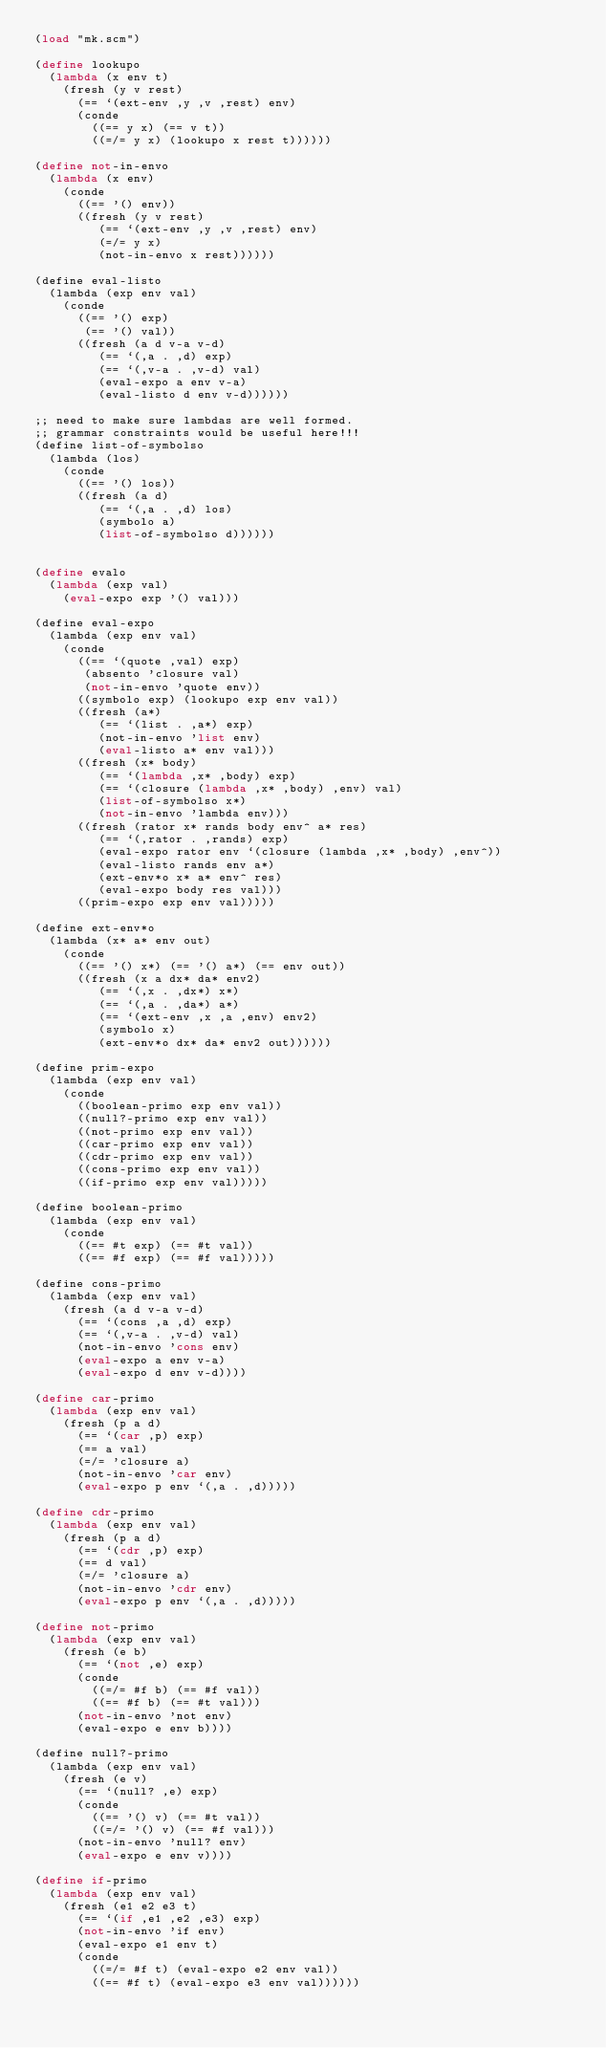<code> <loc_0><loc_0><loc_500><loc_500><_Scheme_>(load "mk.scm")

(define lookupo
  (lambda (x env t)
    (fresh (y v rest)
      (== `(ext-env ,y ,v ,rest) env)
      (conde
        ((== y x) (== v t))
        ((=/= y x) (lookupo x rest t))))))

(define not-in-envo
  (lambda (x env)
    (conde
      ((== '() env))
      ((fresh (y v rest)
         (== `(ext-env ,y ,v ,rest) env)
         (=/= y x)
         (not-in-envo x rest))))))

(define eval-listo
  (lambda (exp env val)
    (conde
      ((== '() exp)
       (== '() val))
      ((fresh (a d v-a v-d)
         (== `(,a . ,d) exp)
         (== `(,v-a . ,v-d) val)
         (eval-expo a env v-a)
         (eval-listo d env v-d))))))

;; need to make sure lambdas are well formed.
;; grammar constraints would be useful here!!!
(define list-of-symbolso
  (lambda (los)
    (conde
      ((== '() los))
      ((fresh (a d)
         (== `(,a . ,d) los)
         (symbolo a)
         (list-of-symbolso d))))))


(define evalo
  (lambda (exp val)
    (eval-expo exp '() val)))

(define eval-expo
  (lambda (exp env val)
    (conde
      ((== `(quote ,val) exp)
       (absento 'closure val)
       (not-in-envo 'quote env))
      ((symbolo exp) (lookupo exp env val))
      ((fresh (a*)
         (== `(list . ,a*) exp)
         (not-in-envo 'list env)
         (eval-listo a* env val)))
      ((fresh (x* body)
         (== `(lambda ,x* ,body) exp)
         (== `(closure (lambda ,x* ,body) ,env) val)
         (list-of-symbolso x*)
         (not-in-envo 'lambda env)))
      ((fresh (rator x* rands body env^ a* res)
         (== `(,rator . ,rands) exp)
         (eval-expo rator env `(closure (lambda ,x* ,body) ,env^))
         (eval-listo rands env a*)
         (ext-env*o x* a* env^ res)
         (eval-expo body res val)))
      ((prim-expo exp env val)))))

(define ext-env*o
  (lambda (x* a* env out)
    (conde
      ((== '() x*) (== '() a*) (== env out))
      ((fresh (x a dx* da* env2)
         (== `(,x . ,dx*) x*)
         (== `(,a . ,da*) a*)
         (== `(ext-env ,x ,a ,env) env2)
         (symbolo x)
         (ext-env*o dx* da* env2 out))))))

(define prim-expo
  (lambda (exp env val)
    (conde
      ((boolean-primo exp env val))
      ((null?-primo exp env val))
      ((not-primo exp env val))
      ((car-primo exp env val))
      ((cdr-primo exp env val))
      ((cons-primo exp env val))
      ((if-primo exp env val)))))

(define boolean-primo
  (lambda (exp env val)
    (conde
      ((== #t exp) (== #t val))
      ((== #f exp) (== #f val)))))

(define cons-primo
  (lambda (exp env val)
    (fresh (a d v-a v-d)
      (== `(cons ,a ,d) exp)
      (== `(,v-a . ,v-d) val)
      (not-in-envo 'cons env)
      (eval-expo a env v-a)
      (eval-expo d env v-d))))

(define car-primo
  (lambda (exp env val)
    (fresh (p a d)
      (== `(car ,p) exp)
      (== a val)
      (=/= 'closure a)
      (not-in-envo 'car env)
      (eval-expo p env `(,a . ,d)))))

(define cdr-primo
  (lambda (exp env val)
    (fresh (p a d)
      (== `(cdr ,p) exp)
      (== d val)
      (=/= 'closure a)
      (not-in-envo 'cdr env)
      (eval-expo p env `(,a . ,d)))))

(define not-primo
  (lambda (exp env val)
    (fresh (e b)
      (== `(not ,e) exp)
      (conde
        ((=/= #f b) (== #f val))
        ((== #f b) (== #t val)))         
      (not-in-envo 'not env)
      (eval-expo e env b))))

(define null?-primo
  (lambda (exp env val)
    (fresh (e v)
      (== `(null? ,e) exp)
      (conde
        ((== '() v) (== #t val))
        ((=/= '() v) (== #f val)))
      (not-in-envo 'null? env)
      (eval-expo e env v))))

(define if-primo
  (lambda (exp env val)
    (fresh (e1 e2 e3 t)
      (== `(if ,e1 ,e2 ,e3) exp)
      (not-in-envo 'if env)
      (eval-expo e1 env t)
      (conde
        ((=/= #f t) (eval-expo e2 env val))
        ((== #f t) (eval-expo e3 env val))))))
</code> 